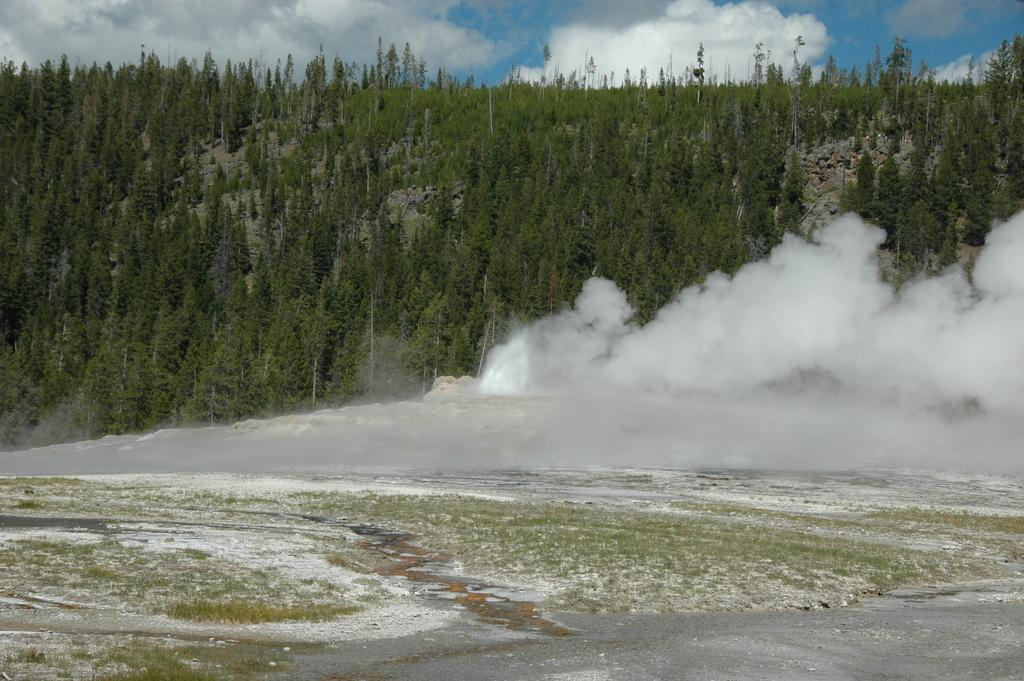What type of surface is visible in the image? There is ground visible in the image. What can be seen on the ground in the image? There is a white colored object on the ground. What is the color of the smoke visible in the image? The smoke visible in the image is white. What type of vegetation is in the background of the image? There are trees in the background of the image. What part of the natural environment is visible in the background of the image? The sky is visible in the background of the image. How much coal is being used in the image? There is no coal present in the image. 